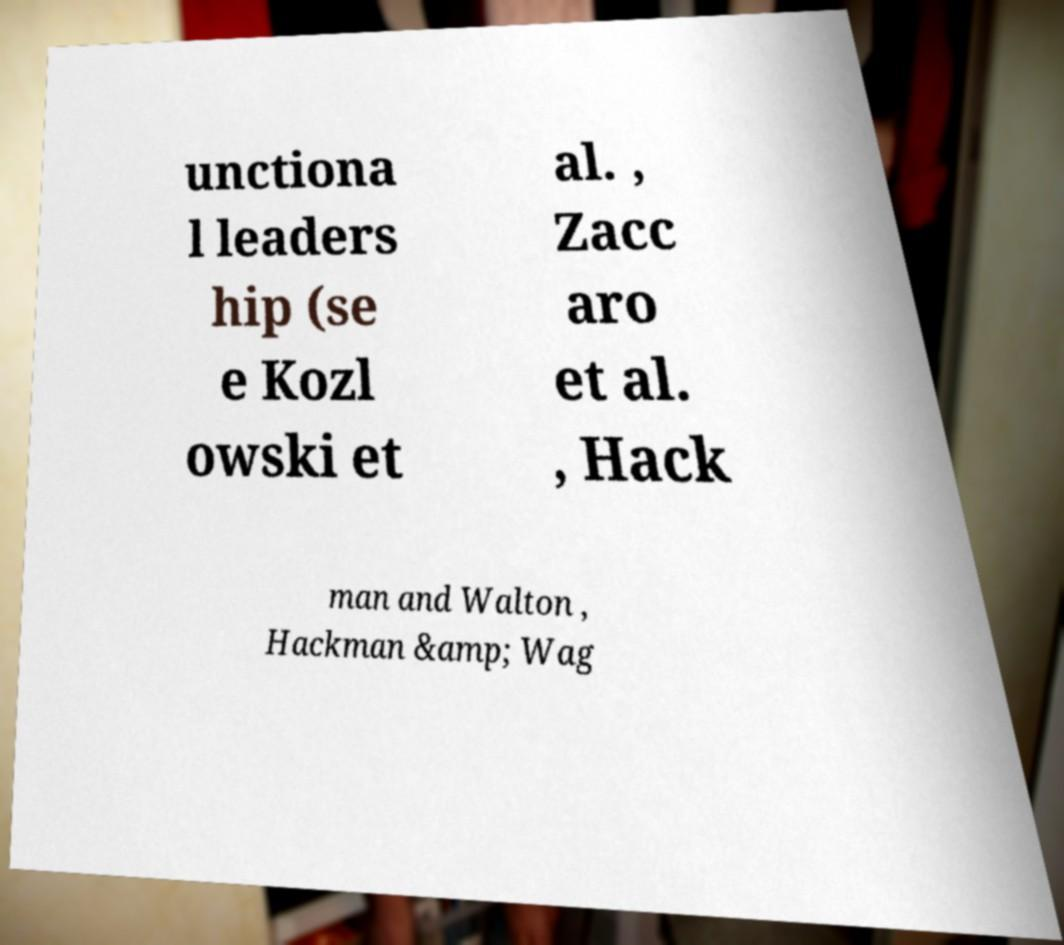I need the written content from this picture converted into text. Can you do that? unctiona l leaders hip (se e Kozl owski et al. , Zacc aro et al. , Hack man and Walton , Hackman &amp; Wag 